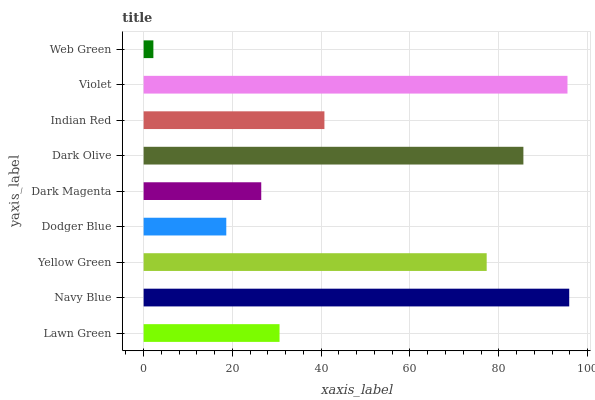Is Web Green the minimum?
Answer yes or no. Yes. Is Navy Blue the maximum?
Answer yes or no. Yes. Is Yellow Green the minimum?
Answer yes or no. No. Is Yellow Green the maximum?
Answer yes or no. No. Is Navy Blue greater than Yellow Green?
Answer yes or no. Yes. Is Yellow Green less than Navy Blue?
Answer yes or no. Yes. Is Yellow Green greater than Navy Blue?
Answer yes or no. No. Is Navy Blue less than Yellow Green?
Answer yes or no. No. Is Indian Red the high median?
Answer yes or no. Yes. Is Indian Red the low median?
Answer yes or no. Yes. Is Dark Magenta the high median?
Answer yes or no. No. Is Dark Magenta the low median?
Answer yes or no. No. 